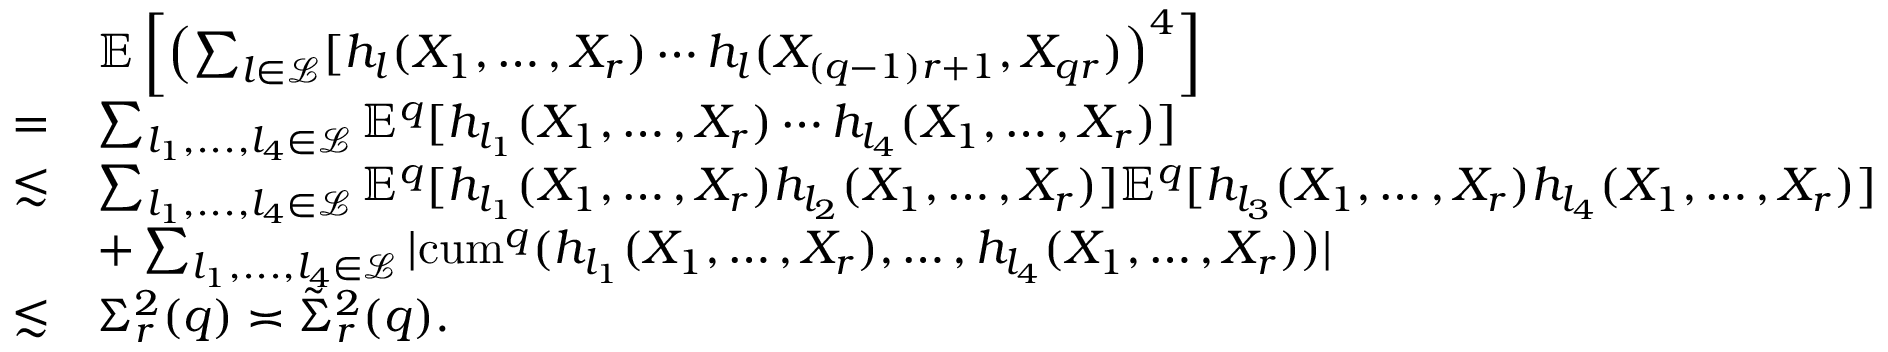<formula> <loc_0><loc_0><loc_500><loc_500>\begin{array} { r l } & { \mathbb { E } \left [ \left ( \sum _ { l \in \mathcal { L } } [ h _ { l } ( X _ { 1 } , \dots , X _ { r } ) \cdots h _ { l } ( X _ { ( q - 1 ) r + 1 } , X _ { q r } ) \right ) ^ { 4 } \right ] } \\ { = } & { \sum _ { l _ { 1 } , \dots , l _ { 4 } \in \mathcal { L } } \mathbb { E } ^ { q } [ h _ { l _ { 1 } } ( X _ { 1 } , \dots , X _ { r } ) \cdots h _ { l _ { 4 } } ( X _ { 1 } , \dots , X _ { r } ) ] } \\ { \lesssim } & { \sum _ { l _ { 1 } , \dots , l _ { 4 } \in \mathcal { L } } \mathbb { E } ^ { q } [ h _ { l _ { 1 } } ( X _ { 1 } , \dots , X _ { r } ) h _ { l _ { 2 } } ( X _ { 1 } , \dots , X _ { r } ) ] \mathbb { E } ^ { q } [ h _ { l _ { 3 } } ( X _ { 1 } , \dots , X _ { r } ) h _ { l _ { 4 } } ( X _ { 1 } , \dots , X _ { r } ) ] } \\ & { + \sum _ { l _ { 1 } , \dots , l _ { 4 } \in \mathcal { L } } | { c u m } ^ { q } ( h _ { l _ { 1 } } ( X _ { 1 } , \dots , X _ { r } ) , \dots , h _ { l _ { 4 } } ( X _ { 1 } , \dots , X _ { r } ) ) | } \\ { \lesssim } & { \Sigma _ { r } ^ { 2 } ( q ) \asymp \tilde { \Sigma } _ { r } ^ { 2 } ( q ) . } \end{array}</formula> 